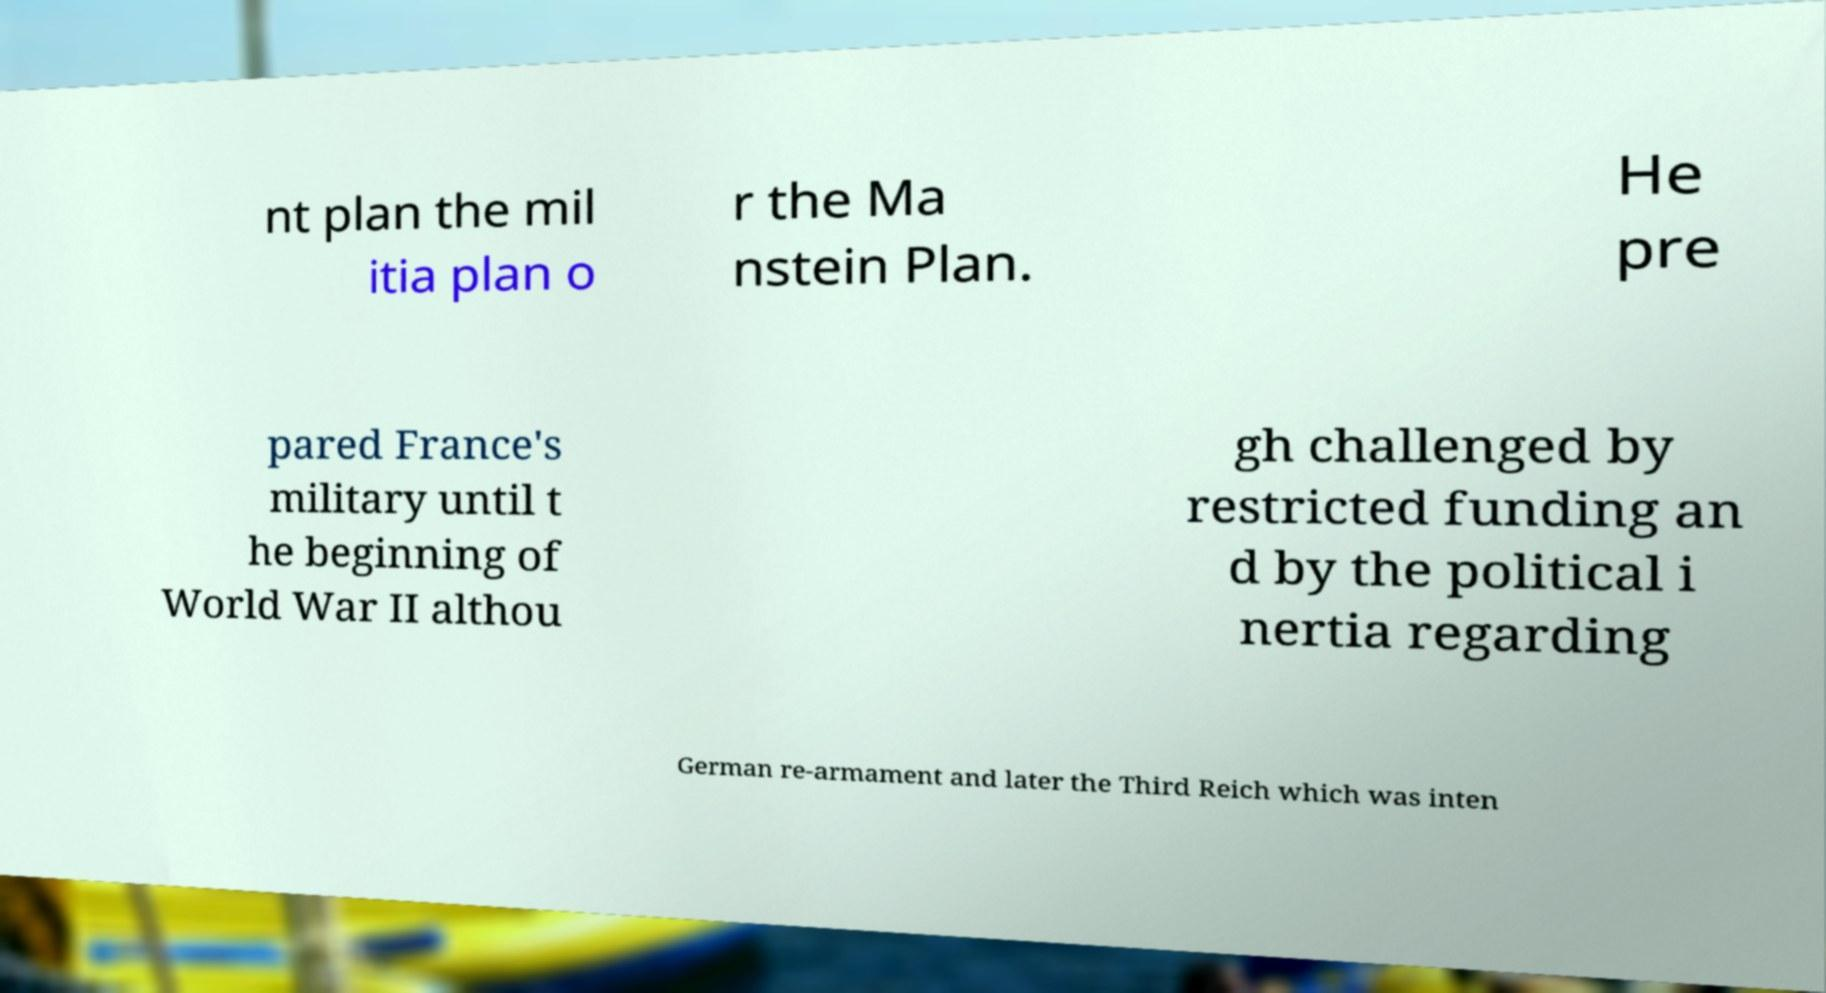Can you read and provide the text displayed in the image?This photo seems to have some interesting text. Can you extract and type it out for me? nt plan the mil itia plan o r the Ma nstein Plan. He pre pared France's military until t he beginning of World War II althou gh challenged by restricted funding an d by the political i nertia regarding German re-armament and later the Third Reich which was inten 